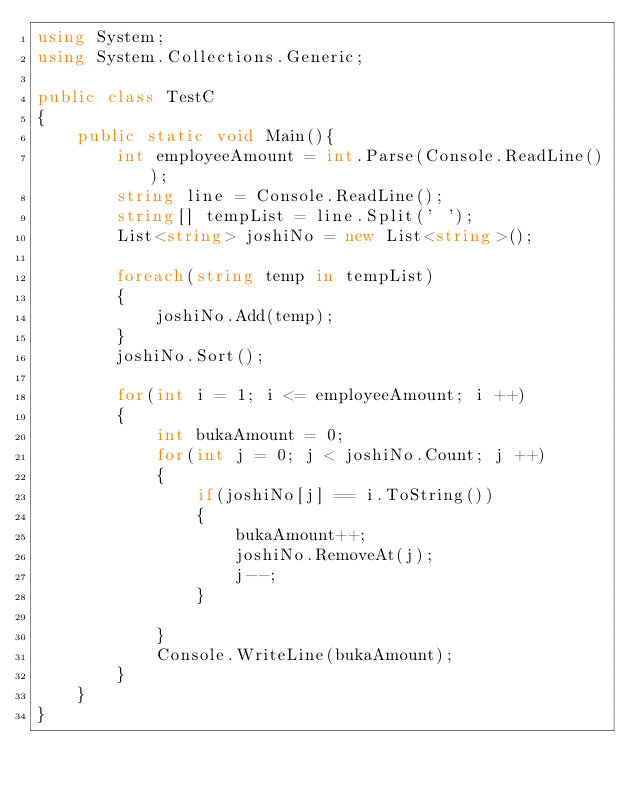<code> <loc_0><loc_0><loc_500><loc_500><_C#_>using System;
using System.Collections.Generic;

public class TestC
{
    public static void Main(){
        int employeeAmount = int.Parse(Console.ReadLine());
        string line = Console.ReadLine();
        string[] tempList = line.Split(' ');
        List<string> joshiNo = new List<string>();

        foreach(string temp in tempList)
        {
            joshiNo.Add(temp);
        }
        joshiNo.Sort();

        for(int i = 1; i <= employeeAmount; i ++)
        {
            int bukaAmount = 0;
            for(int j = 0; j < joshiNo.Count; j ++)
            {
                if(joshiNo[j] == i.ToString())
                {
                    bukaAmount++;
                    joshiNo.RemoveAt(j);
                    j--;
                }
                
            }
            Console.WriteLine(bukaAmount);
        }
    }
}</code> 